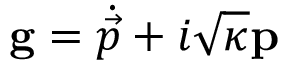<formula> <loc_0><loc_0><loc_500><loc_500>g = \dot { \vec { p } } + i \sqrt { \kappa } p</formula> 